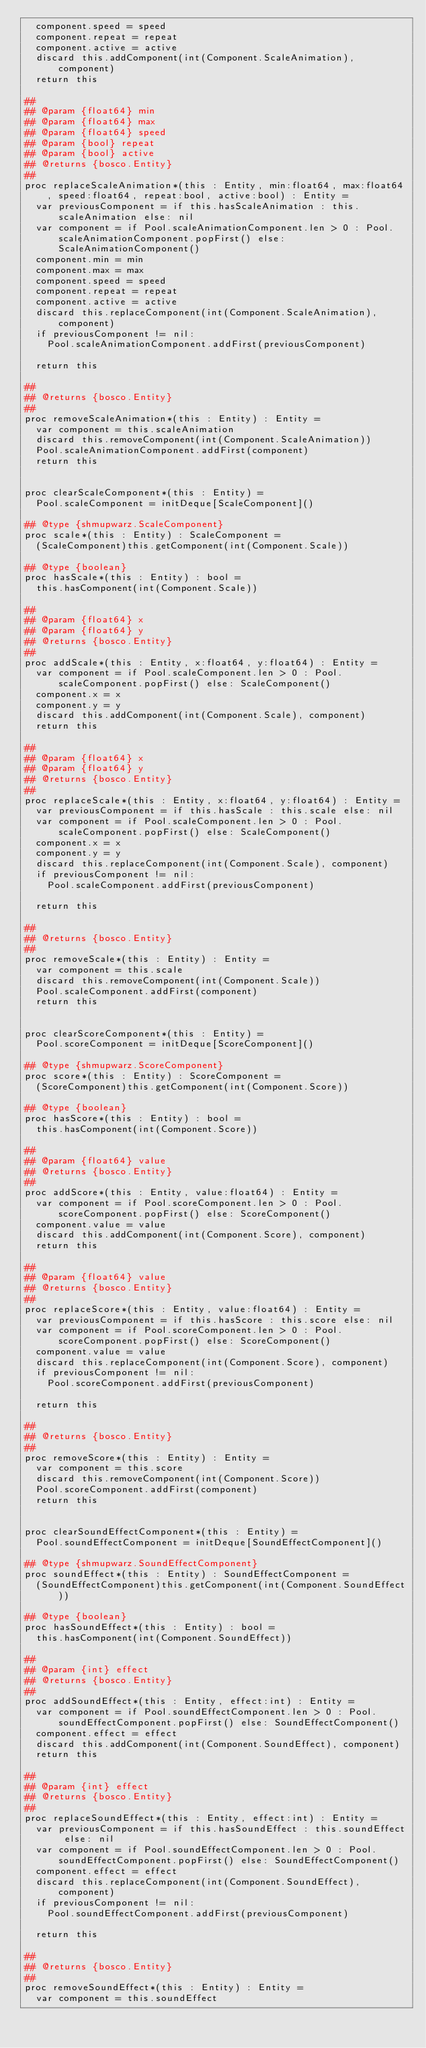Convert code to text. <code><loc_0><loc_0><loc_500><loc_500><_Nim_>  component.speed = speed
  component.repeat = repeat
  component.active = active
  discard this.addComponent(int(Component.ScaleAnimation), component)
  return this

##
## @param {float64} min
## @param {float64} max
## @param {float64} speed
## @param {bool} repeat
## @param {bool} active
## @returns {bosco.Entity}
##
proc replaceScaleAnimation*(this : Entity, min:float64, max:float64, speed:float64, repeat:bool, active:bool) : Entity =
  var previousComponent = if this.hasScaleAnimation : this.scaleAnimation else: nil
  var component = if Pool.scaleAnimationComponent.len > 0 : Pool.scaleAnimationComponent.popFirst() else: ScaleAnimationComponent()
  component.min = min
  component.max = max
  component.speed = speed
  component.repeat = repeat
  component.active = active
  discard this.replaceComponent(int(Component.ScaleAnimation), component)
  if previousComponent != nil:
    Pool.scaleAnimationComponent.addFirst(previousComponent)

  return this

##
## @returns {bosco.Entity}
##
proc removeScaleAnimation*(this : Entity) : Entity =
  var component = this.scaleAnimation
  discard this.removeComponent(int(Component.ScaleAnimation))
  Pool.scaleAnimationComponent.addFirst(component)
  return this


proc clearScaleComponent*(this : Entity) =
  Pool.scaleComponent = initDeque[ScaleComponent]()

## @type {shmupwarz.ScaleComponent} 
proc scale*(this : Entity) : ScaleComponent =
  (ScaleComponent)this.getComponent(int(Component.Scale))

## @type {boolean} 
proc hasScale*(this : Entity) : bool =
  this.hasComponent(int(Component.Scale))

##
## @param {float64} x
## @param {float64} y
## @returns {bosco.Entity}
##
proc addScale*(this : Entity, x:float64, y:float64) : Entity =
  var component = if Pool.scaleComponent.len > 0 : Pool.scaleComponent.popFirst() else: ScaleComponent()
  component.x = x
  component.y = y
  discard this.addComponent(int(Component.Scale), component)
  return this

##
## @param {float64} x
## @param {float64} y
## @returns {bosco.Entity}
##
proc replaceScale*(this : Entity, x:float64, y:float64) : Entity =
  var previousComponent = if this.hasScale : this.scale else: nil
  var component = if Pool.scaleComponent.len > 0 : Pool.scaleComponent.popFirst() else: ScaleComponent()
  component.x = x
  component.y = y
  discard this.replaceComponent(int(Component.Scale), component)
  if previousComponent != nil:
    Pool.scaleComponent.addFirst(previousComponent)

  return this

##
## @returns {bosco.Entity}
##
proc removeScale*(this : Entity) : Entity =
  var component = this.scale
  discard this.removeComponent(int(Component.Scale))
  Pool.scaleComponent.addFirst(component)
  return this


proc clearScoreComponent*(this : Entity) =
  Pool.scoreComponent = initDeque[ScoreComponent]()

## @type {shmupwarz.ScoreComponent} 
proc score*(this : Entity) : ScoreComponent =
  (ScoreComponent)this.getComponent(int(Component.Score))

## @type {boolean} 
proc hasScore*(this : Entity) : bool =
  this.hasComponent(int(Component.Score))

##
## @param {float64} value
## @returns {bosco.Entity}
##
proc addScore*(this : Entity, value:float64) : Entity =
  var component = if Pool.scoreComponent.len > 0 : Pool.scoreComponent.popFirst() else: ScoreComponent()
  component.value = value
  discard this.addComponent(int(Component.Score), component)
  return this

##
## @param {float64} value
## @returns {bosco.Entity}
##
proc replaceScore*(this : Entity, value:float64) : Entity =
  var previousComponent = if this.hasScore : this.score else: nil
  var component = if Pool.scoreComponent.len > 0 : Pool.scoreComponent.popFirst() else: ScoreComponent()
  component.value = value
  discard this.replaceComponent(int(Component.Score), component)
  if previousComponent != nil:
    Pool.scoreComponent.addFirst(previousComponent)

  return this

##
## @returns {bosco.Entity}
##
proc removeScore*(this : Entity) : Entity =
  var component = this.score
  discard this.removeComponent(int(Component.Score))
  Pool.scoreComponent.addFirst(component)
  return this


proc clearSoundEffectComponent*(this : Entity) =
  Pool.soundEffectComponent = initDeque[SoundEffectComponent]()

## @type {shmupwarz.SoundEffectComponent} 
proc soundEffect*(this : Entity) : SoundEffectComponent =
  (SoundEffectComponent)this.getComponent(int(Component.SoundEffect))

## @type {boolean} 
proc hasSoundEffect*(this : Entity) : bool =
  this.hasComponent(int(Component.SoundEffect))

##
## @param {int} effect
## @returns {bosco.Entity}
##
proc addSoundEffect*(this : Entity, effect:int) : Entity =
  var component = if Pool.soundEffectComponent.len > 0 : Pool.soundEffectComponent.popFirst() else: SoundEffectComponent()
  component.effect = effect
  discard this.addComponent(int(Component.SoundEffect), component)
  return this

##
## @param {int} effect
## @returns {bosco.Entity}
##
proc replaceSoundEffect*(this : Entity, effect:int) : Entity =
  var previousComponent = if this.hasSoundEffect : this.soundEffect else: nil
  var component = if Pool.soundEffectComponent.len > 0 : Pool.soundEffectComponent.popFirst() else: SoundEffectComponent()
  component.effect = effect
  discard this.replaceComponent(int(Component.SoundEffect), component)
  if previousComponent != nil:
    Pool.soundEffectComponent.addFirst(previousComponent)

  return this

##
## @returns {bosco.Entity}
##
proc removeSoundEffect*(this : Entity) : Entity =
  var component = this.soundEffect</code> 